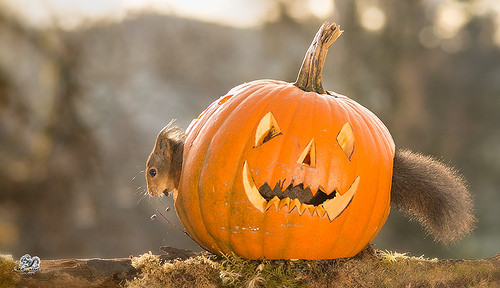<image>
Is the squirrel next to the pumpkin? No. The squirrel is not positioned next to the pumpkin. They are located in different areas of the scene. 